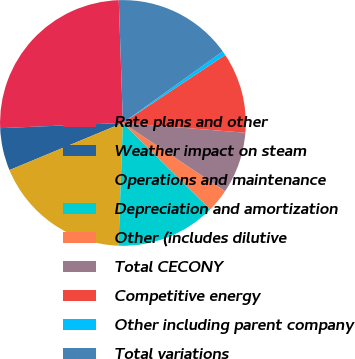<chart> <loc_0><loc_0><loc_500><loc_500><pie_chart><fcel>Rate plans and other<fcel>Weather impact on steam<fcel>Operations and maintenance<fcel>Depreciation and amortization<fcel>Other (includes dilutive<fcel>Total CECONY<fcel>Competitive energy<fcel>Other including parent company<fcel>Total variations<nl><fcel>25.14%<fcel>5.59%<fcel>18.16%<fcel>13.13%<fcel>3.07%<fcel>8.1%<fcel>10.61%<fcel>0.56%<fcel>15.64%<nl></chart> 